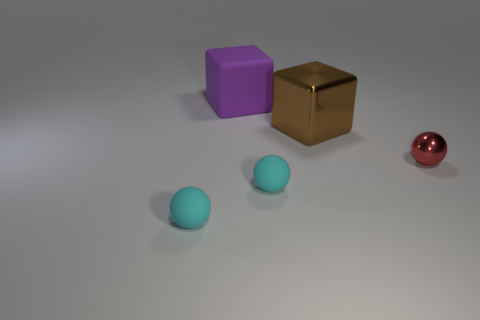How many objects are either objects on the left side of the red ball or big objects?
Your answer should be compact. 4. What is the shape of the shiny thing to the left of the shiny object that is in front of the large brown object?
Provide a succinct answer. Cube. Is there a gray matte ball of the same size as the purple matte cube?
Keep it short and to the point. No. Is the number of brown objects greater than the number of large blue shiny balls?
Your response must be concise. Yes. Do the shiny thing that is on the left side of the small red sphere and the matte thing that is behind the small red metal sphere have the same size?
Ensure brevity in your answer.  Yes. What number of things are both on the left side of the large brown thing and in front of the large matte thing?
Provide a succinct answer. 2. There is a rubber thing that is the same shape as the large metal thing; what is its color?
Provide a succinct answer. Purple. Is the number of brown blocks less than the number of tiny spheres?
Your answer should be compact. Yes. Do the brown metallic object and the block on the left side of the brown metallic cube have the same size?
Provide a short and direct response. Yes. There is a metallic thing that is behind the metallic object that is right of the big metal block; what is its color?
Your answer should be compact. Brown. 